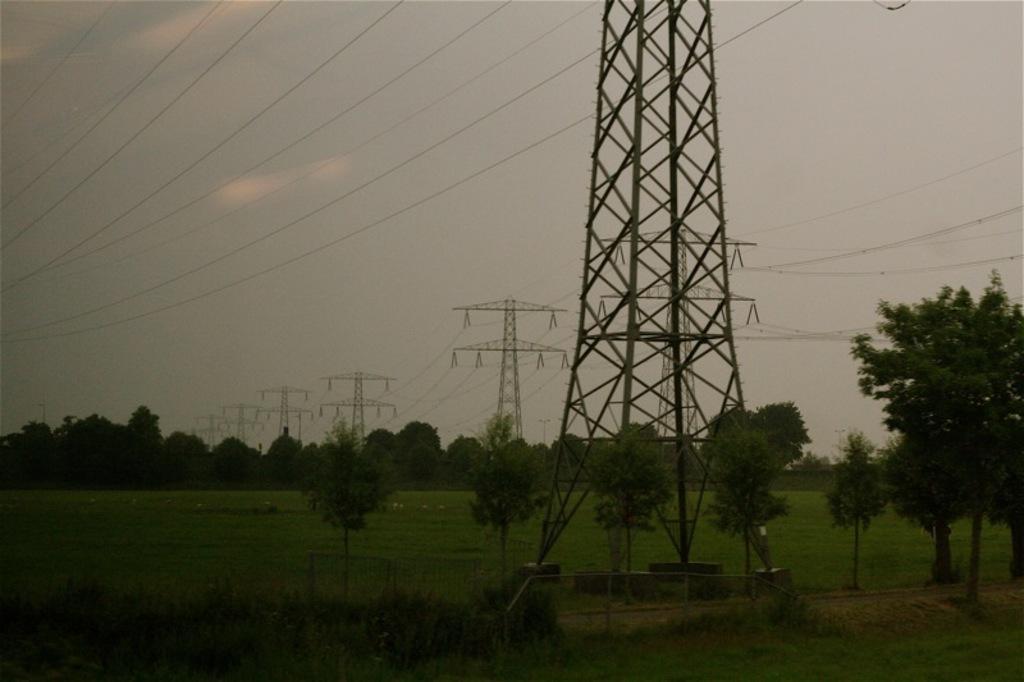Could you give a brief overview of what you see in this image? In this image we can see few trees, grass, towers with wires and the sky in the background. 